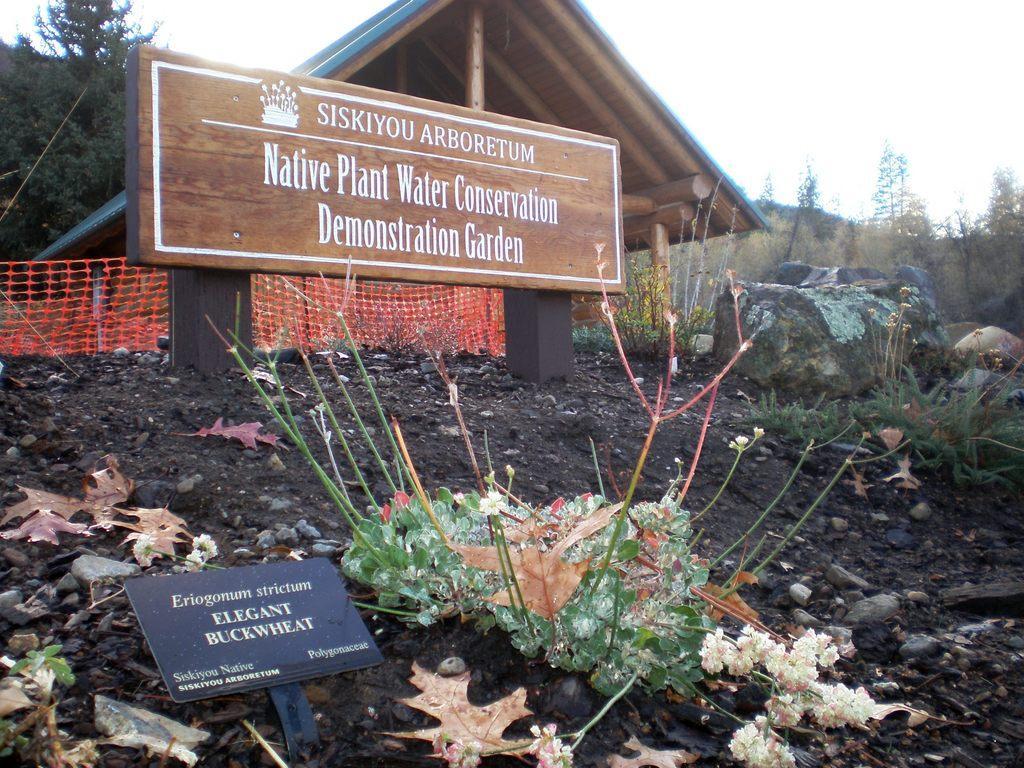How would you summarize this image in a sentence or two? In this picture I can see the boards. I can see trees. I can see the roof of the house. I can see the net. 